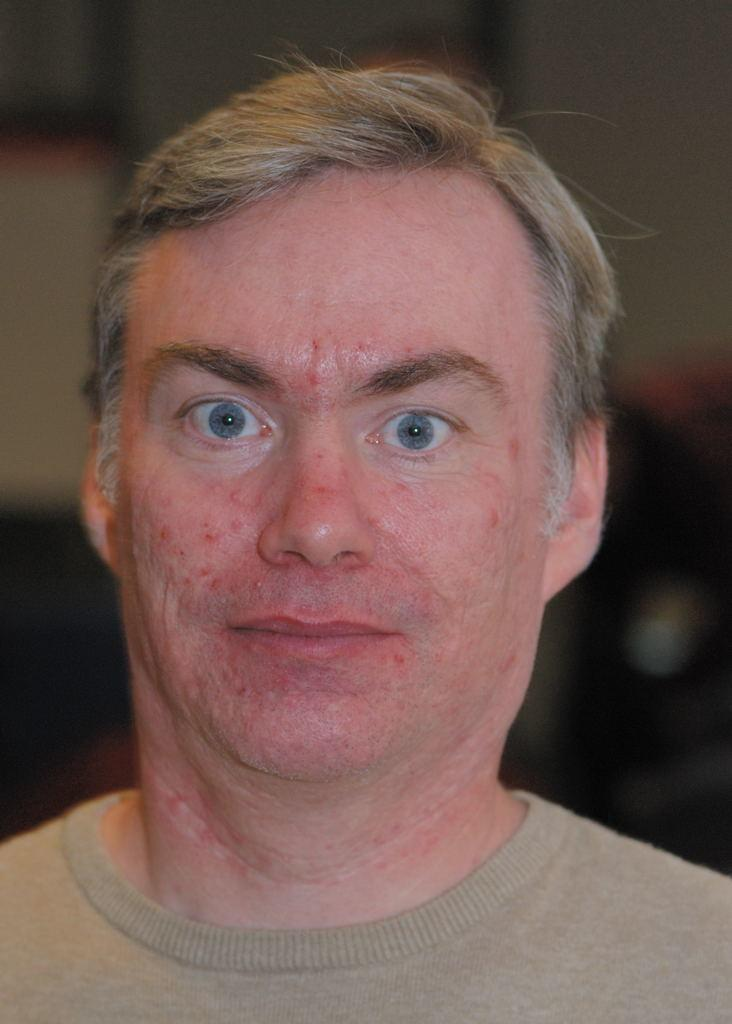Who is the main subject in the image? There is a man in the image. What can be observed about the background of the image? The background of the image is blurred. What type of lettuce is being used as a toothbrush by the man in the image? There is no lettuce or toothbrush present in the image, and the man is not performing any such activity. 